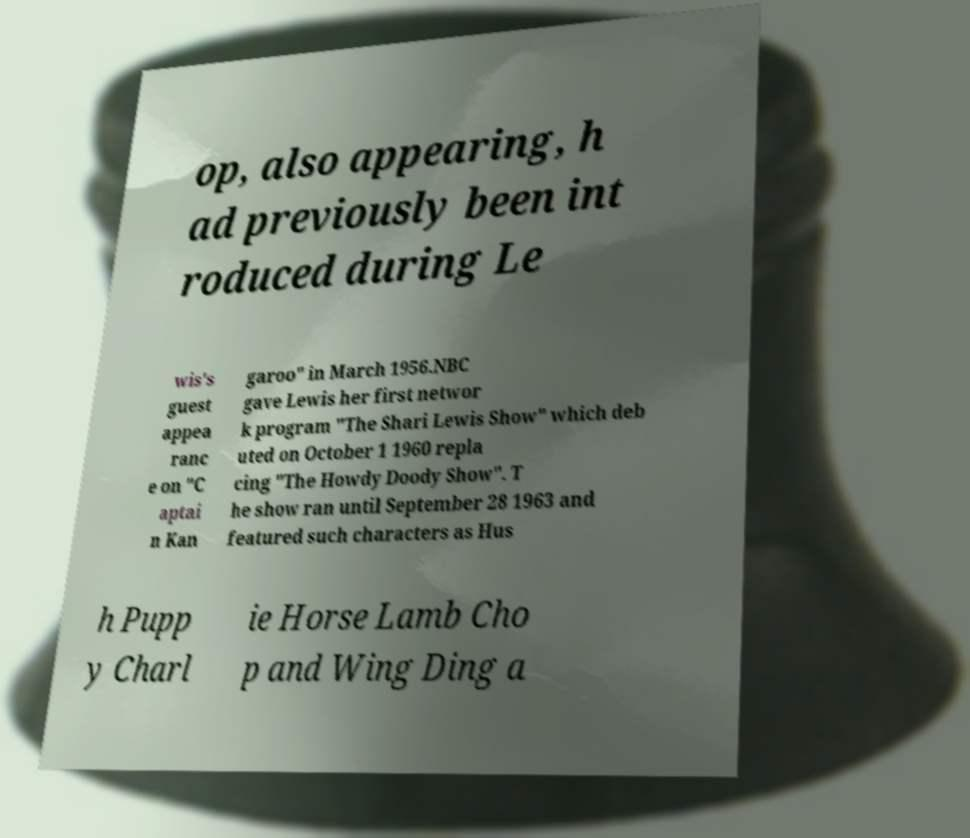What messages or text are displayed in this image? I need them in a readable, typed format. op, also appearing, h ad previously been int roduced during Le wis's guest appea ranc e on "C aptai n Kan garoo" in March 1956.NBC gave Lewis her first networ k program "The Shari Lewis Show" which deb uted on October 1 1960 repla cing "The Howdy Doody Show". T he show ran until September 28 1963 and featured such characters as Hus h Pupp y Charl ie Horse Lamb Cho p and Wing Ding a 